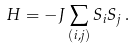Convert formula to latex. <formula><loc_0><loc_0><loc_500><loc_500>H = - J \sum _ { ( i , j ) } S _ { i } S _ { j } \, .</formula> 